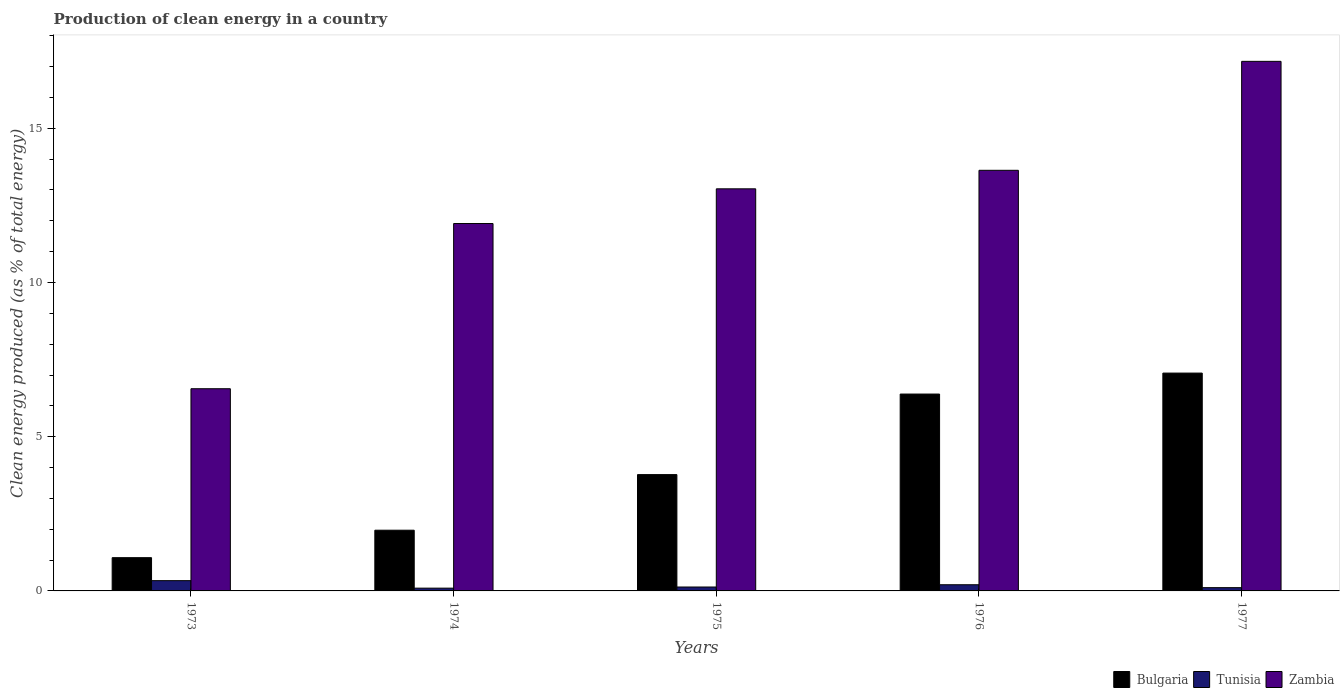What is the label of the 2nd group of bars from the left?
Your answer should be very brief. 1974. What is the percentage of clean energy produced in Zambia in 1975?
Offer a terse response. 13.04. Across all years, what is the maximum percentage of clean energy produced in Bulgaria?
Your answer should be compact. 7.06. Across all years, what is the minimum percentage of clean energy produced in Bulgaria?
Provide a succinct answer. 1.08. In which year was the percentage of clean energy produced in Zambia minimum?
Offer a very short reply. 1973. What is the total percentage of clean energy produced in Bulgaria in the graph?
Give a very brief answer. 20.26. What is the difference between the percentage of clean energy produced in Bulgaria in 1973 and that in 1976?
Keep it short and to the point. -5.3. What is the difference between the percentage of clean energy produced in Tunisia in 1973 and the percentage of clean energy produced in Bulgaria in 1976?
Keep it short and to the point. -6.05. What is the average percentage of clean energy produced in Zambia per year?
Ensure brevity in your answer.  12.46. In the year 1977, what is the difference between the percentage of clean energy produced in Tunisia and percentage of clean energy produced in Bulgaria?
Ensure brevity in your answer.  -6.96. In how many years, is the percentage of clean energy produced in Tunisia greater than 2 %?
Your answer should be compact. 0. What is the ratio of the percentage of clean energy produced in Zambia in 1975 to that in 1976?
Offer a terse response. 0.96. Is the percentage of clean energy produced in Bulgaria in 1975 less than that in 1976?
Offer a terse response. Yes. Is the difference between the percentage of clean energy produced in Tunisia in 1974 and 1976 greater than the difference between the percentage of clean energy produced in Bulgaria in 1974 and 1976?
Keep it short and to the point. Yes. What is the difference between the highest and the second highest percentage of clean energy produced in Zambia?
Your answer should be very brief. 3.53. What is the difference between the highest and the lowest percentage of clean energy produced in Zambia?
Give a very brief answer. 10.61. Is the sum of the percentage of clean energy produced in Tunisia in 1975 and 1976 greater than the maximum percentage of clean energy produced in Zambia across all years?
Offer a terse response. No. What does the 1st bar from the right in 1975 represents?
Provide a short and direct response. Zambia. Is it the case that in every year, the sum of the percentage of clean energy produced in Zambia and percentage of clean energy produced in Tunisia is greater than the percentage of clean energy produced in Bulgaria?
Ensure brevity in your answer.  Yes. How many bars are there?
Offer a very short reply. 15. How many years are there in the graph?
Offer a very short reply. 5. What is the difference between two consecutive major ticks on the Y-axis?
Your answer should be compact. 5. Are the values on the major ticks of Y-axis written in scientific E-notation?
Make the answer very short. No. Does the graph contain any zero values?
Your answer should be compact. No. How many legend labels are there?
Your answer should be compact. 3. How are the legend labels stacked?
Make the answer very short. Horizontal. What is the title of the graph?
Provide a short and direct response. Production of clean energy in a country. Does "China" appear as one of the legend labels in the graph?
Provide a succinct answer. No. What is the label or title of the Y-axis?
Make the answer very short. Clean energy produced (as % of total energy). What is the Clean energy produced (as % of total energy) of Bulgaria in 1973?
Your answer should be very brief. 1.08. What is the Clean energy produced (as % of total energy) in Tunisia in 1973?
Ensure brevity in your answer.  0.33. What is the Clean energy produced (as % of total energy) of Zambia in 1973?
Your response must be concise. 6.56. What is the Clean energy produced (as % of total energy) of Bulgaria in 1974?
Provide a succinct answer. 1.97. What is the Clean energy produced (as % of total energy) of Tunisia in 1974?
Provide a short and direct response. 0.09. What is the Clean energy produced (as % of total energy) in Zambia in 1974?
Give a very brief answer. 11.91. What is the Clean energy produced (as % of total energy) in Bulgaria in 1975?
Your response must be concise. 3.77. What is the Clean energy produced (as % of total energy) in Tunisia in 1975?
Make the answer very short. 0.13. What is the Clean energy produced (as % of total energy) in Zambia in 1975?
Offer a terse response. 13.04. What is the Clean energy produced (as % of total energy) in Bulgaria in 1976?
Provide a short and direct response. 6.38. What is the Clean energy produced (as % of total energy) in Tunisia in 1976?
Offer a very short reply. 0.2. What is the Clean energy produced (as % of total energy) of Zambia in 1976?
Provide a succinct answer. 13.64. What is the Clean energy produced (as % of total energy) in Bulgaria in 1977?
Your answer should be compact. 7.06. What is the Clean energy produced (as % of total energy) of Tunisia in 1977?
Ensure brevity in your answer.  0.11. What is the Clean energy produced (as % of total energy) in Zambia in 1977?
Offer a very short reply. 17.17. Across all years, what is the maximum Clean energy produced (as % of total energy) of Bulgaria?
Your answer should be compact. 7.06. Across all years, what is the maximum Clean energy produced (as % of total energy) in Tunisia?
Provide a succinct answer. 0.33. Across all years, what is the maximum Clean energy produced (as % of total energy) in Zambia?
Your answer should be very brief. 17.17. Across all years, what is the minimum Clean energy produced (as % of total energy) in Bulgaria?
Your response must be concise. 1.08. Across all years, what is the minimum Clean energy produced (as % of total energy) in Tunisia?
Provide a short and direct response. 0.09. Across all years, what is the minimum Clean energy produced (as % of total energy) in Zambia?
Ensure brevity in your answer.  6.56. What is the total Clean energy produced (as % of total energy) of Bulgaria in the graph?
Offer a very short reply. 20.26. What is the total Clean energy produced (as % of total energy) of Tunisia in the graph?
Ensure brevity in your answer.  0.86. What is the total Clean energy produced (as % of total energy) of Zambia in the graph?
Ensure brevity in your answer.  62.31. What is the difference between the Clean energy produced (as % of total energy) in Bulgaria in 1973 and that in 1974?
Keep it short and to the point. -0.89. What is the difference between the Clean energy produced (as % of total energy) of Tunisia in 1973 and that in 1974?
Offer a very short reply. 0.24. What is the difference between the Clean energy produced (as % of total energy) in Zambia in 1973 and that in 1974?
Provide a succinct answer. -5.36. What is the difference between the Clean energy produced (as % of total energy) in Bulgaria in 1973 and that in 1975?
Make the answer very short. -2.69. What is the difference between the Clean energy produced (as % of total energy) in Tunisia in 1973 and that in 1975?
Give a very brief answer. 0.21. What is the difference between the Clean energy produced (as % of total energy) of Zambia in 1973 and that in 1975?
Keep it short and to the point. -6.48. What is the difference between the Clean energy produced (as % of total energy) in Bulgaria in 1973 and that in 1976?
Keep it short and to the point. -5.3. What is the difference between the Clean energy produced (as % of total energy) of Tunisia in 1973 and that in 1976?
Your answer should be very brief. 0.13. What is the difference between the Clean energy produced (as % of total energy) of Zambia in 1973 and that in 1976?
Your response must be concise. -7.08. What is the difference between the Clean energy produced (as % of total energy) in Bulgaria in 1973 and that in 1977?
Make the answer very short. -5.98. What is the difference between the Clean energy produced (as % of total energy) in Tunisia in 1973 and that in 1977?
Offer a terse response. 0.23. What is the difference between the Clean energy produced (as % of total energy) of Zambia in 1973 and that in 1977?
Your response must be concise. -10.61. What is the difference between the Clean energy produced (as % of total energy) of Bulgaria in 1974 and that in 1975?
Your answer should be very brief. -1.8. What is the difference between the Clean energy produced (as % of total energy) of Tunisia in 1974 and that in 1975?
Your answer should be very brief. -0.04. What is the difference between the Clean energy produced (as % of total energy) in Zambia in 1974 and that in 1975?
Give a very brief answer. -1.12. What is the difference between the Clean energy produced (as % of total energy) of Bulgaria in 1974 and that in 1976?
Provide a short and direct response. -4.41. What is the difference between the Clean energy produced (as % of total energy) in Tunisia in 1974 and that in 1976?
Offer a very short reply. -0.11. What is the difference between the Clean energy produced (as % of total energy) in Zambia in 1974 and that in 1976?
Your answer should be compact. -1.73. What is the difference between the Clean energy produced (as % of total energy) of Bulgaria in 1974 and that in 1977?
Make the answer very short. -5.09. What is the difference between the Clean energy produced (as % of total energy) in Tunisia in 1974 and that in 1977?
Offer a terse response. -0.02. What is the difference between the Clean energy produced (as % of total energy) of Zambia in 1974 and that in 1977?
Provide a succinct answer. -5.26. What is the difference between the Clean energy produced (as % of total energy) in Bulgaria in 1975 and that in 1976?
Ensure brevity in your answer.  -2.61. What is the difference between the Clean energy produced (as % of total energy) of Tunisia in 1975 and that in 1976?
Keep it short and to the point. -0.07. What is the difference between the Clean energy produced (as % of total energy) of Zambia in 1975 and that in 1976?
Your answer should be compact. -0.6. What is the difference between the Clean energy produced (as % of total energy) of Bulgaria in 1975 and that in 1977?
Your response must be concise. -3.29. What is the difference between the Clean energy produced (as % of total energy) in Tunisia in 1975 and that in 1977?
Your answer should be very brief. 0.02. What is the difference between the Clean energy produced (as % of total energy) of Zambia in 1975 and that in 1977?
Keep it short and to the point. -4.13. What is the difference between the Clean energy produced (as % of total energy) in Bulgaria in 1976 and that in 1977?
Your answer should be very brief. -0.68. What is the difference between the Clean energy produced (as % of total energy) of Tunisia in 1976 and that in 1977?
Your answer should be compact. 0.09. What is the difference between the Clean energy produced (as % of total energy) in Zambia in 1976 and that in 1977?
Your response must be concise. -3.53. What is the difference between the Clean energy produced (as % of total energy) in Bulgaria in 1973 and the Clean energy produced (as % of total energy) in Tunisia in 1974?
Offer a very short reply. 0.99. What is the difference between the Clean energy produced (as % of total energy) in Bulgaria in 1973 and the Clean energy produced (as % of total energy) in Zambia in 1974?
Your response must be concise. -10.83. What is the difference between the Clean energy produced (as % of total energy) of Tunisia in 1973 and the Clean energy produced (as % of total energy) of Zambia in 1974?
Offer a terse response. -11.58. What is the difference between the Clean energy produced (as % of total energy) in Bulgaria in 1973 and the Clean energy produced (as % of total energy) in Tunisia in 1975?
Your answer should be compact. 0.95. What is the difference between the Clean energy produced (as % of total energy) in Bulgaria in 1973 and the Clean energy produced (as % of total energy) in Zambia in 1975?
Your response must be concise. -11.96. What is the difference between the Clean energy produced (as % of total energy) of Tunisia in 1973 and the Clean energy produced (as % of total energy) of Zambia in 1975?
Offer a very short reply. -12.7. What is the difference between the Clean energy produced (as % of total energy) of Bulgaria in 1973 and the Clean energy produced (as % of total energy) of Tunisia in 1976?
Give a very brief answer. 0.88. What is the difference between the Clean energy produced (as % of total energy) of Bulgaria in 1973 and the Clean energy produced (as % of total energy) of Zambia in 1976?
Provide a short and direct response. -12.56. What is the difference between the Clean energy produced (as % of total energy) of Tunisia in 1973 and the Clean energy produced (as % of total energy) of Zambia in 1976?
Ensure brevity in your answer.  -13.3. What is the difference between the Clean energy produced (as % of total energy) in Bulgaria in 1973 and the Clean energy produced (as % of total energy) in Tunisia in 1977?
Keep it short and to the point. 0.97. What is the difference between the Clean energy produced (as % of total energy) in Bulgaria in 1973 and the Clean energy produced (as % of total energy) in Zambia in 1977?
Make the answer very short. -16.09. What is the difference between the Clean energy produced (as % of total energy) of Tunisia in 1973 and the Clean energy produced (as % of total energy) of Zambia in 1977?
Give a very brief answer. -16.84. What is the difference between the Clean energy produced (as % of total energy) in Bulgaria in 1974 and the Clean energy produced (as % of total energy) in Tunisia in 1975?
Ensure brevity in your answer.  1.84. What is the difference between the Clean energy produced (as % of total energy) in Bulgaria in 1974 and the Clean energy produced (as % of total energy) in Zambia in 1975?
Your answer should be compact. -11.07. What is the difference between the Clean energy produced (as % of total energy) of Tunisia in 1974 and the Clean energy produced (as % of total energy) of Zambia in 1975?
Ensure brevity in your answer.  -12.95. What is the difference between the Clean energy produced (as % of total energy) in Bulgaria in 1974 and the Clean energy produced (as % of total energy) in Tunisia in 1976?
Give a very brief answer. 1.77. What is the difference between the Clean energy produced (as % of total energy) of Bulgaria in 1974 and the Clean energy produced (as % of total energy) of Zambia in 1976?
Make the answer very short. -11.67. What is the difference between the Clean energy produced (as % of total energy) of Tunisia in 1974 and the Clean energy produced (as % of total energy) of Zambia in 1976?
Provide a succinct answer. -13.55. What is the difference between the Clean energy produced (as % of total energy) of Bulgaria in 1974 and the Clean energy produced (as % of total energy) of Tunisia in 1977?
Give a very brief answer. 1.86. What is the difference between the Clean energy produced (as % of total energy) in Bulgaria in 1974 and the Clean energy produced (as % of total energy) in Zambia in 1977?
Keep it short and to the point. -15.2. What is the difference between the Clean energy produced (as % of total energy) in Tunisia in 1974 and the Clean energy produced (as % of total energy) in Zambia in 1977?
Your response must be concise. -17.08. What is the difference between the Clean energy produced (as % of total energy) in Bulgaria in 1975 and the Clean energy produced (as % of total energy) in Tunisia in 1976?
Provide a short and direct response. 3.57. What is the difference between the Clean energy produced (as % of total energy) in Bulgaria in 1975 and the Clean energy produced (as % of total energy) in Zambia in 1976?
Your answer should be very brief. -9.87. What is the difference between the Clean energy produced (as % of total energy) of Tunisia in 1975 and the Clean energy produced (as % of total energy) of Zambia in 1976?
Make the answer very short. -13.51. What is the difference between the Clean energy produced (as % of total energy) in Bulgaria in 1975 and the Clean energy produced (as % of total energy) in Tunisia in 1977?
Your answer should be compact. 3.67. What is the difference between the Clean energy produced (as % of total energy) in Bulgaria in 1975 and the Clean energy produced (as % of total energy) in Zambia in 1977?
Ensure brevity in your answer.  -13.4. What is the difference between the Clean energy produced (as % of total energy) in Tunisia in 1975 and the Clean energy produced (as % of total energy) in Zambia in 1977?
Offer a very short reply. -17.04. What is the difference between the Clean energy produced (as % of total energy) in Bulgaria in 1976 and the Clean energy produced (as % of total energy) in Tunisia in 1977?
Give a very brief answer. 6.28. What is the difference between the Clean energy produced (as % of total energy) of Bulgaria in 1976 and the Clean energy produced (as % of total energy) of Zambia in 1977?
Your answer should be very brief. -10.79. What is the difference between the Clean energy produced (as % of total energy) of Tunisia in 1976 and the Clean energy produced (as % of total energy) of Zambia in 1977?
Offer a very short reply. -16.97. What is the average Clean energy produced (as % of total energy) in Bulgaria per year?
Keep it short and to the point. 4.05. What is the average Clean energy produced (as % of total energy) in Tunisia per year?
Your answer should be very brief. 0.17. What is the average Clean energy produced (as % of total energy) in Zambia per year?
Keep it short and to the point. 12.46. In the year 1973, what is the difference between the Clean energy produced (as % of total energy) in Bulgaria and Clean energy produced (as % of total energy) in Tunisia?
Provide a short and direct response. 0.75. In the year 1973, what is the difference between the Clean energy produced (as % of total energy) in Bulgaria and Clean energy produced (as % of total energy) in Zambia?
Your answer should be very brief. -5.48. In the year 1973, what is the difference between the Clean energy produced (as % of total energy) of Tunisia and Clean energy produced (as % of total energy) of Zambia?
Offer a terse response. -6.22. In the year 1974, what is the difference between the Clean energy produced (as % of total energy) in Bulgaria and Clean energy produced (as % of total energy) in Tunisia?
Provide a short and direct response. 1.88. In the year 1974, what is the difference between the Clean energy produced (as % of total energy) in Bulgaria and Clean energy produced (as % of total energy) in Zambia?
Your answer should be compact. -9.94. In the year 1974, what is the difference between the Clean energy produced (as % of total energy) in Tunisia and Clean energy produced (as % of total energy) in Zambia?
Offer a terse response. -11.82. In the year 1975, what is the difference between the Clean energy produced (as % of total energy) of Bulgaria and Clean energy produced (as % of total energy) of Tunisia?
Provide a short and direct response. 3.64. In the year 1975, what is the difference between the Clean energy produced (as % of total energy) of Bulgaria and Clean energy produced (as % of total energy) of Zambia?
Keep it short and to the point. -9.26. In the year 1975, what is the difference between the Clean energy produced (as % of total energy) of Tunisia and Clean energy produced (as % of total energy) of Zambia?
Offer a terse response. -12.91. In the year 1976, what is the difference between the Clean energy produced (as % of total energy) of Bulgaria and Clean energy produced (as % of total energy) of Tunisia?
Your response must be concise. 6.18. In the year 1976, what is the difference between the Clean energy produced (as % of total energy) of Bulgaria and Clean energy produced (as % of total energy) of Zambia?
Offer a terse response. -7.25. In the year 1976, what is the difference between the Clean energy produced (as % of total energy) of Tunisia and Clean energy produced (as % of total energy) of Zambia?
Provide a succinct answer. -13.44. In the year 1977, what is the difference between the Clean energy produced (as % of total energy) of Bulgaria and Clean energy produced (as % of total energy) of Tunisia?
Your answer should be very brief. 6.96. In the year 1977, what is the difference between the Clean energy produced (as % of total energy) of Bulgaria and Clean energy produced (as % of total energy) of Zambia?
Give a very brief answer. -10.11. In the year 1977, what is the difference between the Clean energy produced (as % of total energy) of Tunisia and Clean energy produced (as % of total energy) of Zambia?
Offer a terse response. -17.06. What is the ratio of the Clean energy produced (as % of total energy) in Bulgaria in 1973 to that in 1974?
Your response must be concise. 0.55. What is the ratio of the Clean energy produced (as % of total energy) of Tunisia in 1973 to that in 1974?
Ensure brevity in your answer.  3.7. What is the ratio of the Clean energy produced (as % of total energy) in Zambia in 1973 to that in 1974?
Provide a succinct answer. 0.55. What is the ratio of the Clean energy produced (as % of total energy) of Bulgaria in 1973 to that in 1975?
Ensure brevity in your answer.  0.29. What is the ratio of the Clean energy produced (as % of total energy) of Tunisia in 1973 to that in 1975?
Your answer should be compact. 2.63. What is the ratio of the Clean energy produced (as % of total energy) of Zambia in 1973 to that in 1975?
Your answer should be compact. 0.5. What is the ratio of the Clean energy produced (as % of total energy) in Bulgaria in 1973 to that in 1976?
Make the answer very short. 0.17. What is the ratio of the Clean energy produced (as % of total energy) in Tunisia in 1973 to that in 1976?
Provide a succinct answer. 1.66. What is the ratio of the Clean energy produced (as % of total energy) in Zambia in 1973 to that in 1976?
Make the answer very short. 0.48. What is the ratio of the Clean energy produced (as % of total energy) of Bulgaria in 1973 to that in 1977?
Offer a very short reply. 0.15. What is the ratio of the Clean energy produced (as % of total energy) of Tunisia in 1973 to that in 1977?
Give a very brief answer. 3.14. What is the ratio of the Clean energy produced (as % of total energy) of Zambia in 1973 to that in 1977?
Provide a short and direct response. 0.38. What is the ratio of the Clean energy produced (as % of total energy) of Bulgaria in 1974 to that in 1975?
Give a very brief answer. 0.52. What is the ratio of the Clean energy produced (as % of total energy) of Tunisia in 1974 to that in 1975?
Ensure brevity in your answer.  0.71. What is the ratio of the Clean energy produced (as % of total energy) of Zambia in 1974 to that in 1975?
Make the answer very short. 0.91. What is the ratio of the Clean energy produced (as % of total energy) of Bulgaria in 1974 to that in 1976?
Your response must be concise. 0.31. What is the ratio of the Clean energy produced (as % of total energy) of Tunisia in 1974 to that in 1976?
Your answer should be very brief. 0.45. What is the ratio of the Clean energy produced (as % of total energy) in Zambia in 1974 to that in 1976?
Provide a short and direct response. 0.87. What is the ratio of the Clean energy produced (as % of total energy) in Bulgaria in 1974 to that in 1977?
Make the answer very short. 0.28. What is the ratio of the Clean energy produced (as % of total energy) in Tunisia in 1974 to that in 1977?
Provide a short and direct response. 0.85. What is the ratio of the Clean energy produced (as % of total energy) of Zambia in 1974 to that in 1977?
Make the answer very short. 0.69. What is the ratio of the Clean energy produced (as % of total energy) in Bulgaria in 1975 to that in 1976?
Give a very brief answer. 0.59. What is the ratio of the Clean energy produced (as % of total energy) in Tunisia in 1975 to that in 1976?
Make the answer very short. 0.63. What is the ratio of the Clean energy produced (as % of total energy) of Zambia in 1975 to that in 1976?
Ensure brevity in your answer.  0.96. What is the ratio of the Clean energy produced (as % of total energy) of Bulgaria in 1975 to that in 1977?
Provide a succinct answer. 0.53. What is the ratio of the Clean energy produced (as % of total energy) in Tunisia in 1975 to that in 1977?
Give a very brief answer. 1.2. What is the ratio of the Clean energy produced (as % of total energy) in Zambia in 1975 to that in 1977?
Make the answer very short. 0.76. What is the ratio of the Clean energy produced (as % of total energy) in Bulgaria in 1976 to that in 1977?
Your answer should be compact. 0.9. What is the ratio of the Clean energy produced (as % of total energy) of Tunisia in 1976 to that in 1977?
Your answer should be very brief. 1.89. What is the ratio of the Clean energy produced (as % of total energy) in Zambia in 1976 to that in 1977?
Provide a short and direct response. 0.79. What is the difference between the highest and the second highest Clean energy produced (as % of total energy) of Bulgaria?
Your response must be concise. 0.68. What is the difference between the highest and the second highest Clean energy produced (as % of total energy) in Tunisia?
Provide a short and direct response. 0.13. What is the difference between the highest and the second highest Clean energy produced (as % of total energy) of Zambia?
Offer a terse response. 3.53. What is the difference between the highest and the lowest Clean energy produced (as % of total energy) of Bulgaria?
Keep it short and to the point. 5.98. What is the difference between the highest and the lowest Clean energy produced (as % of total energy) in Tunisia?
Give a very brief answer. 0.24. What is the difference between the highest and the lowest Clean energy produced (as % of total energy) in Zambia?
Ensure brevity in your answer.  10.61. 